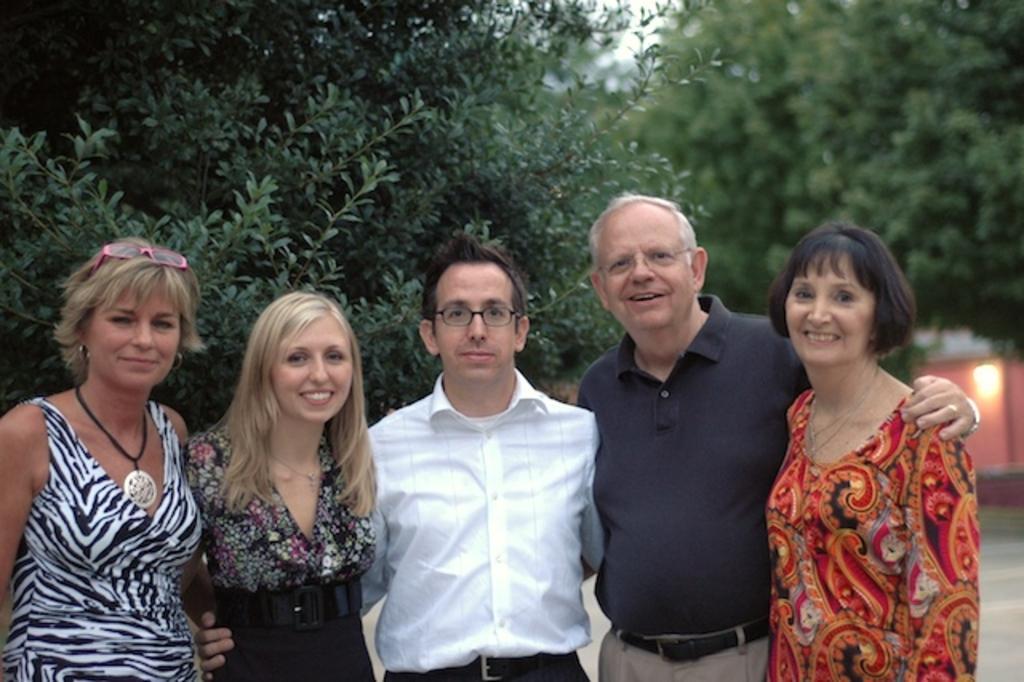Can you describe this image briefly? In this picture there are group of people standing and smiling. At the back there is a building and there is a light on the wall and there are trees. At the top there is sky. 